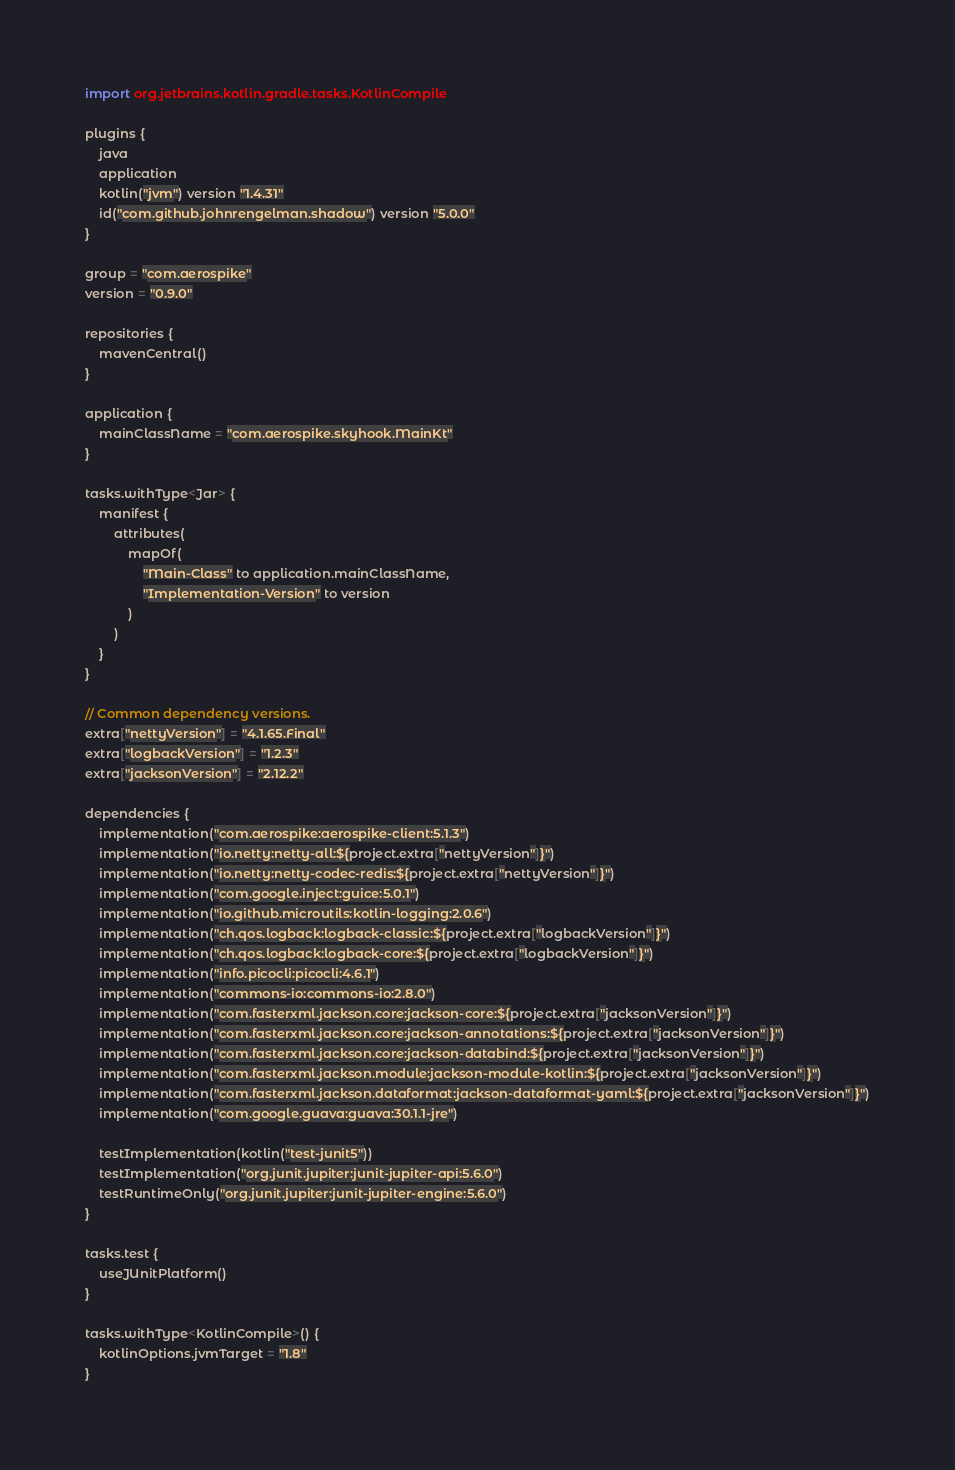Convert code to text. <code><loc_0><loc_0><loc_500><loc_500><_Kotlin_>import org.jetbrains.kotlin.gradle.tasks.KotlinCompile

plugins {
    java
    application
    kotlin("jvm") version "1.4.31"
    id("com.github.johnrengelman.shadow") version "5.0.0"
}

group = "com.aerospike"
version = "0.9.0"

repositories {
    mavenCentral()
}

application {
    mainClassName = "com.aerospike.skyhook.MainKt"
}

tasks.withType<Jar> {
    manifest {
        attributes(
            mapOf(
                "Main-Class" to application.mainClassName,
                "Implementation-Version" to version
            )
        )
    }
}

// Common dependency versions.
extra["nettyVersion"] = "4.1.65.Final"
extra["logbackVersion"] = "1.2.3"
extra["jacksonVersion"] = "2.12.2"

dependencies {
    implementation("com.aerospike:aerospike-client:5.1.3")
    implementation("io.netty:netty-all:${project.extra["nettyVersion"]}")
    implementation("io.netty:netty-codec-redis:${project.extra["nettyVersion"]}")
    implementation("com.google.inject:guice:5.0.1")
    implementation("io.github.microutils:kotlin-logging:2.0.6")
    implementation("ch.qos.logback:logback-classic:${project.extra["logbackVersion"]}")
    implementation("ch.qos.logback:logback-core:${project.extra["logbackVersion"]}")
    implementation("info.picocli:picocli:4.6.1")
    implementation("commons-io:commons-io:2.8.0")
    implementation("com.fasterxml.jackson.core:jackson-core:${project.extra["jacksonVersion"]}")
    implementation("com.fasterxml.jackson.core:jackson-annotations:${project.extra["jacksonVersion"]}")
    implementation("com.fasterxml.jackson.core:jackson-databind:${project.extra["jacksonVersion"]}")
    implementation("com.fasterxml.jackson.module:jackson-module-kotlin:${project.extra["jacksonVersion"]}")
    implementation("com.fasterxml.jackson.dataformat:jackson-dataformat-yaml:${project.extra["jacksonVersion"]}")
    implementation("com.google.guava:guava:30.1.1-jre")

    testImplementation(kotlin("test-junit5"))
    testImplementation("org.junit.jupiter:junit-jupiter-api:5.6.0")
    testRuntimeOnly("org.junit.jupiter:junit-jupiter-engine:5.6.0")
}

tasks.test {
    useJUnitPlatform()
}

tasks.withType<KotlinCompile>() {
    kotlinOptions.jvmTarget = "1.8"
}
</code> 